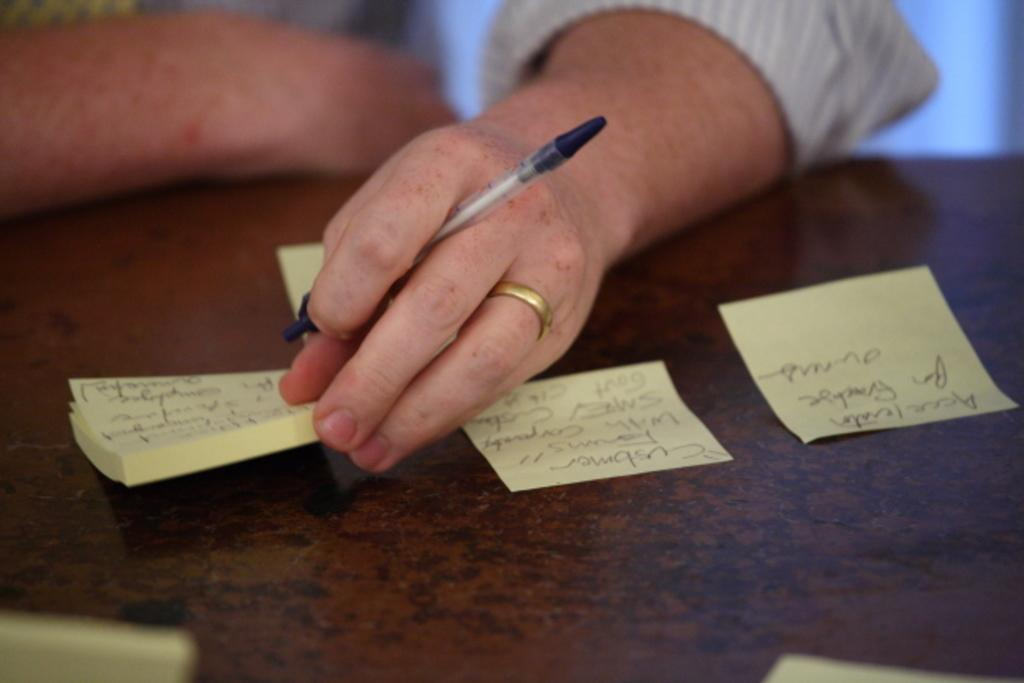Who is present in the image? There is a person in the image. What is the person holding in his hand? The person is holding a pen and papers in his hand. What can be seen on the table in the image? There are papers on the table. Can you describe the content of the papers? There is text written on the papers. What type of grass is growing on the person's head in the image? There is no grass growing on the person's head in the image. How does the ant's behavior change when it encounters the pen in the image? There are no ants present in the image, so their behavior cannot be observed in relation to the pen. 